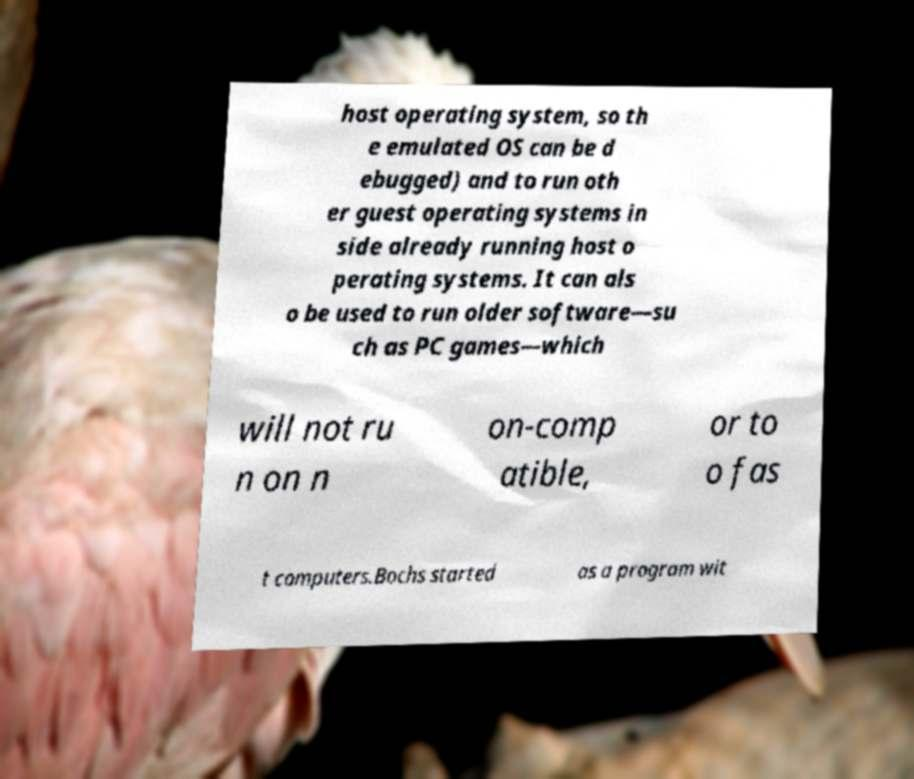Could you assist in decoding the text presented in this image and type it out clearly? host operating system, so th e emulated OS can be d ebugged) and to run oth er guest operating systems in side already running host o perating systems. It can als o be used to run older software—su ch as PC games—which will not ru n on n on-comp atible, or to o fas t computers.Bochs started as a program wit 